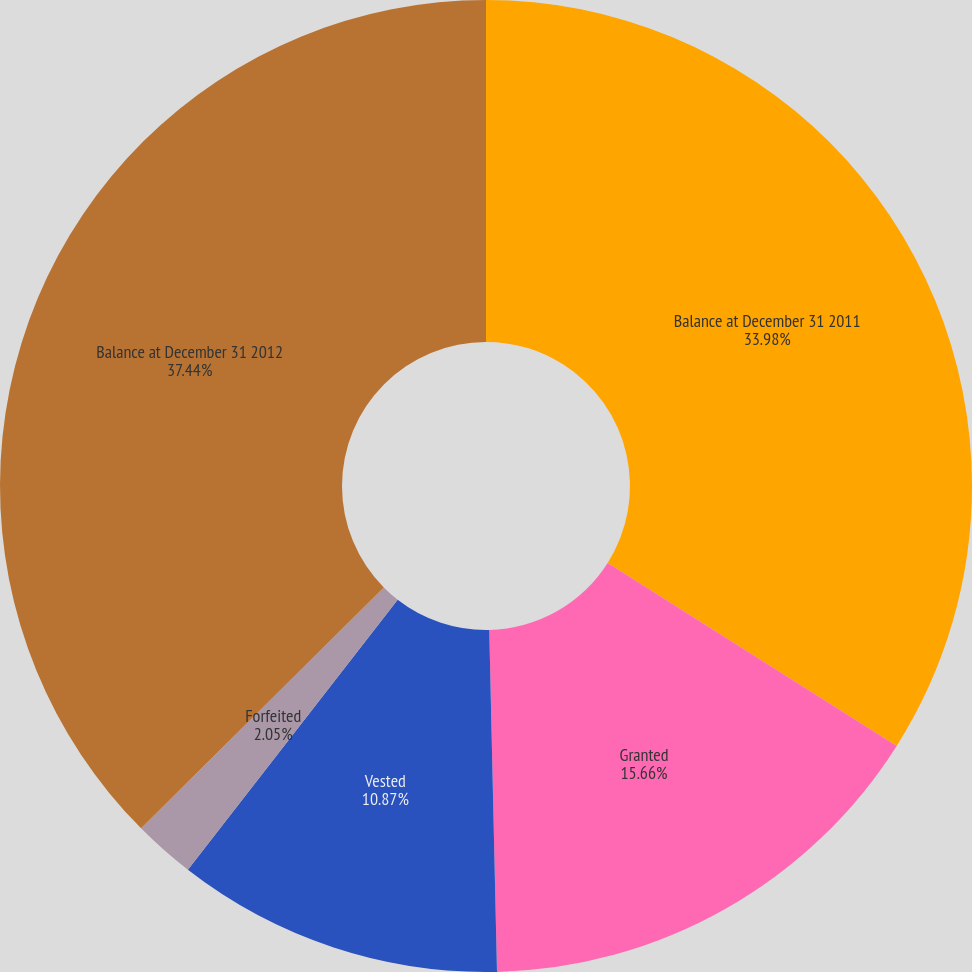<chart> <loc_0><loc_0><loc_500><loc_500><pie_chart><fcel>Balance at December 31 2011<fcel>Granted<fcel>Vested<fcel>Forfeited<fcel>Balance at December 31 2012<nl><fcel>33.98%<fcel>15.66%<fcel>10.87%<fcel>2.05%<fcel>37.44%<nl></chart> 